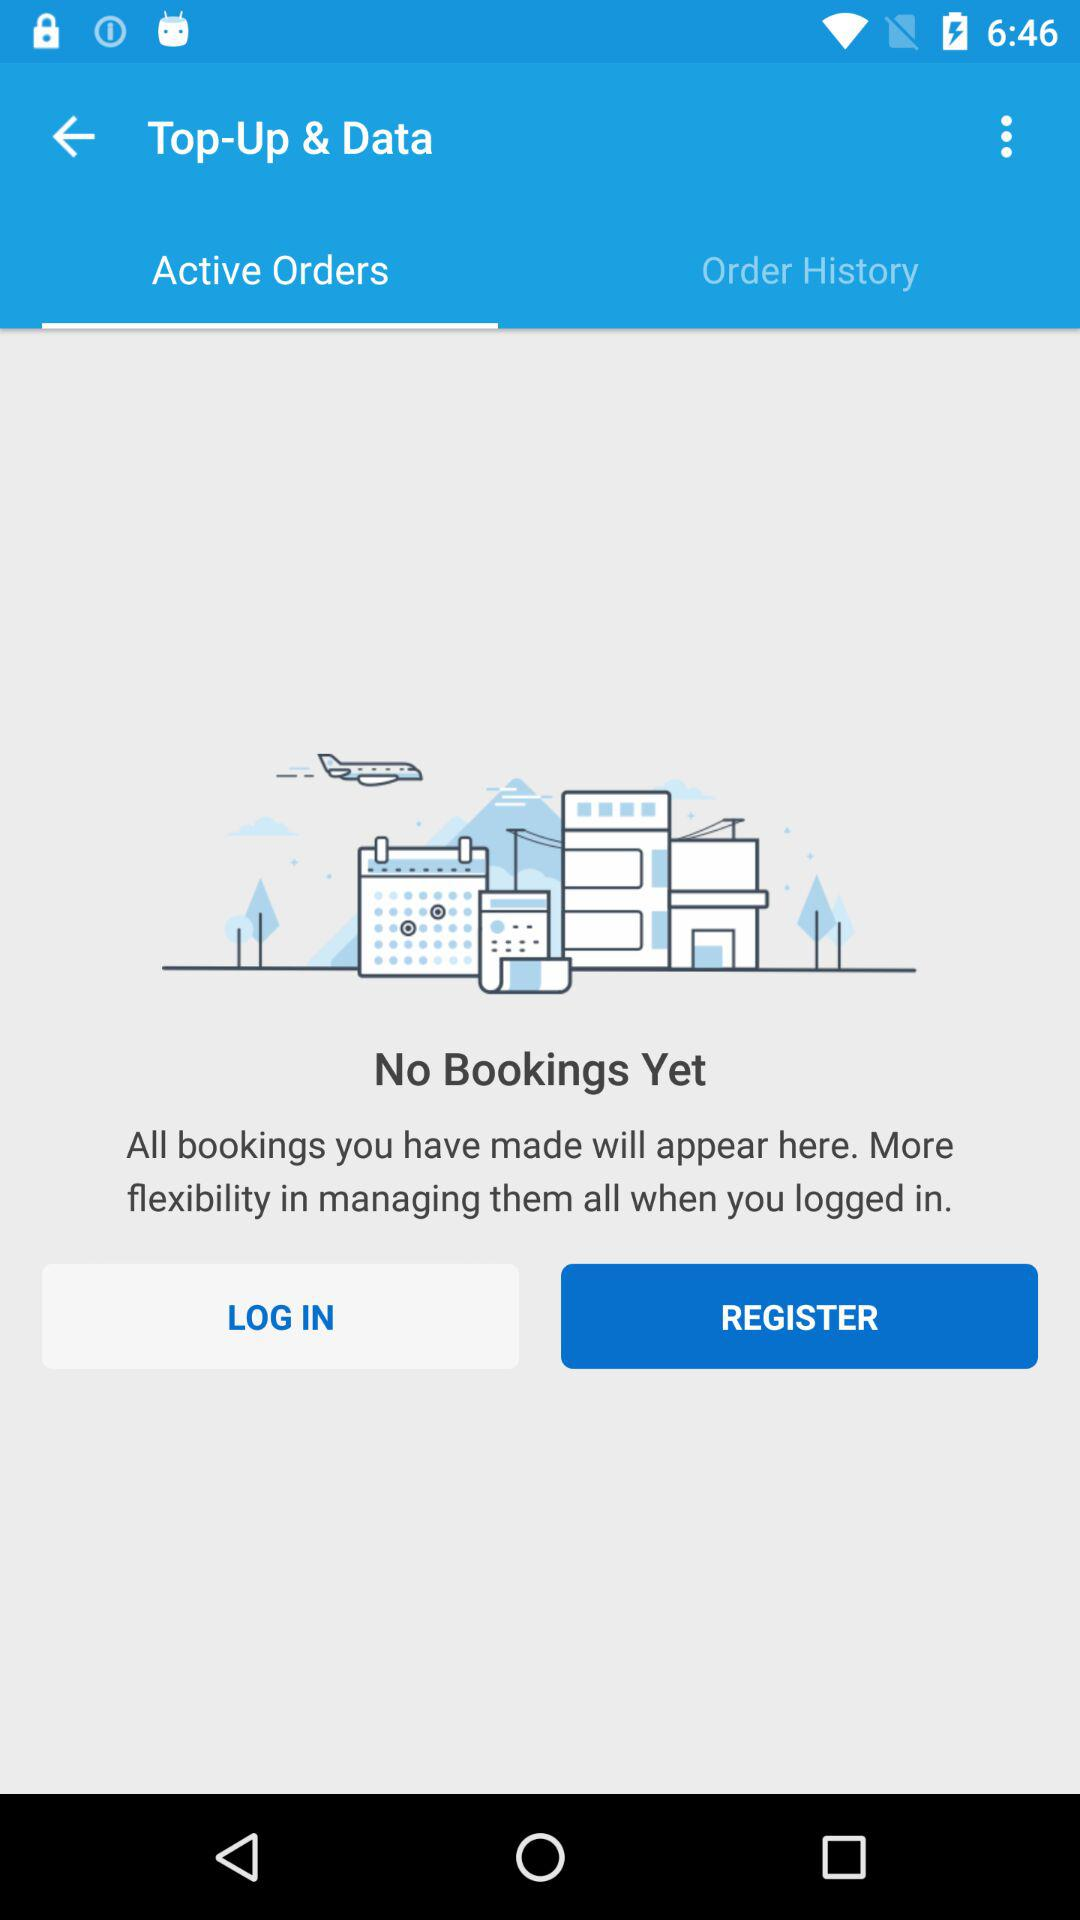Which tab is selected? The selected tab is "Active Orders". 